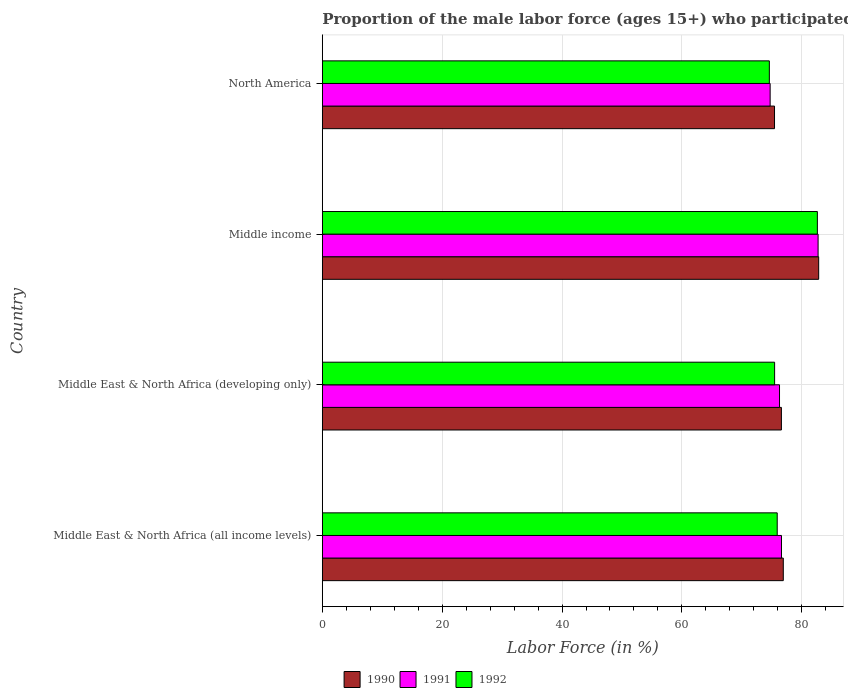How many different coloured bars are there?
Provide a succinct answer. 3. Are the number of bars per tick equal to the number of legend labels?
Offer a very short reply. Yes. Are the number of bars on each tick of the Y-axis equal?
Your answer should be compact. Yes. How many bars are there on the 2nd tick from the top?
Give a very brief answer. 3. What is the label of the 4th group of bars from the top?
Your answer should be very brief. Middle East & North Africa (all income levels). What is the proportion of the male labor force who participated in production in 1991 in Middle East & North Africa (developing only)?
Your answer should be compact. 76.29. Across all countries, what is the maximum proportion of the male labor force who participated in production in 1991?
Make the answer very short. 82.73. Across all countries, what is the minimum proportion of the male labor force who participated in production in 1991?
Give a very brief answer. 74.73. In which country was the proportion of the male labor force who participated in production in 1991 maximum?
Ensure brevity in your answer.  Middle income. What is the total proportion of the male labor force who participated in production in 1990 in the graph?
Keep it short and to the point. 311.83. What is the difference between the proportion of the male labor force who participated in production in 1991 in Middle East & North Africa (all income levels) and that in Middle income?
Ensure brevity in your answer.  -6.11. What is the difference between the proportion of the male labor force who participated in production in 1991 in Middle income and the proportion of the male labor force who participated in production in 1992 in Middle East & North Africa (all income levels)?
Give a very brief answer. 6.82. What is the average proportion of the male labor force who participated in production in 1991 per country?
Offer a terse response. 77.6. What is the difference between the proportion of the male labor force who participated in production in 1990 and proportion of the male labor force who participated in production in 1992 in Middle East & North Africa (developing only)?
Your answer should be compact. 1.13. What is the ratio of the proportion of the male labor force who participated in production in 1991 in Middle East & North Africa (all income levels) to that in Middle income?
Offer a very short reply. 0.93. Is the difference between the proportion of the male labor force who participated in production in 1990 in Middle East & North Africa (all income levels) and North America greater than the difference between the proportion of the male labor force who participated in production in 1992 in Middle East & North Africa (all income levels) and North America?
Give a very brief answer. Yes. What is the difference between the highest and the second highest proportion of the male labor force who participated in production in 1992?
Your answer should be very brief. 6.7. What is the difference between the highest and the lowest proportion of the male labor force who participated in production in 1992?
Your answer should be very brief. 8.02. In how many countries, is the proportion of the male labor force who participated in production in 1992 greater than the average proportion of the male labor force who participated in production in 1992 taken over all countries?
Provide a succinct answer. 1. Is the sum of the proportion of the male labor force who participated in production in 1992 in Middle East & North Africa (all income levels) and North America greater than the maximum proportion of the male labor force who participated in production in 1991 across all countries?
Offer a terse response. Yes. What does the 1st bar from the top in Middle East & North Africa (all income levels) represents?
Your response must be concise. 1992. Is it the case that in every country, the sum of the proportion of the male labor force who participated in production in 1992 and proportion of the male labor force who participated in production in 1991 is greater than the proportion of the male labor force who participated in production in 1990?
Provide a short and direct response. Yes. How many countries are there in the graph?
Provide a succinct answer. 4. Are the values on the major ticks of X-axis written in scientific E-notation?
Give a very brief answer. No. Does the graph contain any zero values?
Your answer should be compact. No. What is the title of the graph?
Your answer should be very brief. Proportion of the male labor force (ages 15+) who participated in production. Does "1995" appear as one of the legend labels in the graph?
Provide a short and direct response. No. What is the label or title of the X-axis?
Provide a succinct answer. Labor Force (in %). What is the Labor Force (in %) of 1990 in Middle East & North Africa (all income levels)?
Offer a terse response. 76.93. What is the Labor Force (in %) of 1991 in Middle East & North Africa (all income levels)?
Ensure brevity in your answer.  76.62. What is the Labor Force (in %) of 1992 in Middle East & North Africa (all income levels)?
Your answer should be very brief. 75.91. What is the Labor Force (in %) of 1990 in Middle East & North Africa (developing only)?
Your response must be concise. 76.61. What is the Labor Force (in %) in 1991 in Middle East & North Africa (developing only)?
Give a very brief answer. 76.29. What is the Labor Force (in %) of 1992 in Middle East & North Africa (developing only)?
Provide a succinct answer. 75.48. What is the Labor Force (in %) of 1990 in Middle income?
Your answer should be very brief. 82.83. What is the Labor Force (in %) of 1991 in Middle income?
Provide a short and direct response. 82.73. What is the Labor Force (in %) of 1992 in Middle income?
Provide a short and direct response. 82.61. What is the Labor Force (in %) of 1990 in North America?
Keep it short and to the point. 75.46. What is the Labor Force (in %) of 1991 in North America?
Your answer should be compact. 74.73. What is the Labor Force (in %) of 1992 in North America?
Offer a terse response. 74.6. Across all countries, what is the maximum Labor Force (in %) in 1990?
Your answer should be very brief. 82.83. Across all countries, what is the maximum Labor Force (in %) in 1991?
Your answer should be compact. 82.73. Across all countries, what is the maximum Labor Force (in %) in 1992?
Ensure brevity in your answer.  82.61. Across all countries, what is the minimum Labor Force (in %) in 1990?
Your answer should be compact. 75.46. Across all countries, what is the minimum Labor Force (in %) in 1991?
Your answer should be compact. 74.73. Across all countries, what is the minimum Labor Force (in %) of 1992?
Your answer should be compact. 74.6. What is the total Labor Force (in %) of 1990 in the graph?
Your answer should be very brief. 311.83. What is the total Labor Force (in %) of 1991 in the graph?
Your answer should be very brief. 310.38. What is the total Labor Force (in %) of 1992 in the graph?
Your answer should be very brief. 308.6. What is the difference between the Labor Force (in %) in 1990 in Middle East & North Africa (all income levels) and that in Middle East & North Africa (developing only)?
Your answer should be compact. 0.32. What is the difference between the Labor Force (in %) of 1991 in Middle East & North Africa (all income levels) and that in Middle East & North Africa (developing only)?
Offer a terse response. 0.33. What is the difference between the Labor Force (in %) in 1992 in Middle East & North Africa (all income levels) and that in Middle East & North Africa (developing only)?
Keep it short and to the point. 0.44. What is the difference between the Labor Force (in %) of 1990 in Middle East & North Africa (all income levels) and that in Middle income?
Your answer should be compact. -5.9. What is the difference between the Labor Force (in %) in 1991 in Middle East & North Africa (all income levels) and that in Middle income?
Offer a very short reply. -6.11. What is the difference between the Labor Force (in %) of 1992 in Middle East & North Africa (all income levels) and that in Middle income?
Offer a terse response. -6.7. What is the difference between the Labor Force (in %) of 1990 in Middle East & North Africa (all income levels) and that in North America?
Provide a short and direct response. 1.46. What is the difference between the Labor Force (in %) in 1991 in Middle East & North Africa (all income levels) and that in North America?
Offer a very short reply. 1.89. What is the difference between the Labor Force (in %) in 1992 in Middle East & North Africa (all income levels) and that in North America?
Offer a very short reply. 1.31. What is the difference between the Labor Force (in %) in 1990 in Middle East & North Africa (developing only) and that in Middle income?
Give a very brief answer. -6.22. What is the difference between the Labor Force (in %) of 1991 in Middle East & North Africa (developing only) and that in Middle income?
Provide a short and direct response. -6.44. What is the difference between the Labor Force (in %) of 1992 in Middle East & North Africa (developing only) and that in Middle income?
Give a very brief answer. -7.14. What is the difference between the Labor Force (in %) in 1990 in Middle East & North Africa (developing only) and that in North America?
Keep it short and to the point. 1.15. What is the difference between the Labor Force (in %) of 1991 in Middle East & North Africa (developing only) and that in North America?
Ensure brevity in your answer.  1.56. What is the difference between the Labor Force (in %) in 1992 in Middle East & North Africa (developing only) and that in North America?
Offer a very short reply. 0.88. What is the difference between the Labor Force (in %) in 1990 in Middle income and that in North America?
Your answer should be compact. 7.37. What is the difference between the Labor Force (in %) in 1991 in Middle income and that in North America?
Offer a terse response. 8. What is the difference between the Labor Force (in %) of 1992 in Middle income and that in North America?
Your response must be concise. 8.02. What is the difference between the Labor Force (in %) of 1990 in Middle East & North Africa (all income levels) and the Labor Force (in %) of 1991 in Middle East & North Africa (developing only)?
Your response must be concise. 0.63. What is the difference between the Labor Force (in %) of 1990 in Middle East & North Africa (all income levels) and the Labor Force (in %) of 1992 in Middle East & North Africa (developing only)?
Give a very brief answer. 1.45. What is the difference between the Labor Force (in %) in 1991 in Middle East & North Africa (all income levels) and the Labor Force (in %) in 1992 in Middle East & North Africa (developing only)?
Your answer should be very brief. 1.15. What is the difference between the Labor Force (in %) in 1990 in Middle East & North Africa (all income levels) and the Labor Force (in %) in 1991 in Middle income?
Ensure brevity in your answer.  -5.81. What is the difference between the Labor Force (in %) of 1990 in Middle East & North Africa (all income levels) and the Labor Force (in %) of 1992 in Middle income?
Give a very brief answer. -5.69. What is the difference between the Labor Force (in %) in 1991 in Middle East & North Africa (all income levels) and the Labor Force (in %) in 1992 in Middle income?
Give a very brief answer. -5.99. What is the difference between the Labor Force (in %) in 1990 in Middle East & North Africa (all income levels) and the Labor Force (in %) in 1991 in North America?
Your response must be concise. 2.2. What is the difference between the Labor Force (in %) in 1990 in Middle East & North Africa (all income levels) and the Labor Force (in %) in 1992 in North America?
Keep it short and to the point. 2.33. What is the difference between the Labor Force (in %) in 1991 in Middle East & North Africa (all income levels) and the Labor Force (in %) in 1992 in North America?
Provide a succinct answer. 2.03. What is the difference between the Labor Force (in %) of 1990 in Middle East & North Africa (developing only) and the Labor Force (in %) of 1991 in Middle income?
Your answer should be compact. -6.12. What is the difference between the Labor Force (in %) in 1990 in Middle East & North Africa (developing only) and the Labor Force (in %) in 1992 in Middle income?
Provide a short and direct response. -6. What is the difference between the Labor Force (in %) in 1991 in Middle East & North Africa (developing only) and the Labor Force (in %) in 1992 in Middle income?
Your answer should be compact. -6.32. What is the difference between the Labor Force (in %) of 1990 in Middle East & North Africa (developing only) and the Labor Force (in %) of 1991 in North America?
Your answer should be compact. 1.88. What is the difference between the Labor Force (in %) in 1990 in Middle East & North Africa (developing only) and the Labor Force (in %) in 1992 in North America?
Ensure brevity in your answer.  2.01. What is the difference between the Labor Force (in %) in 1991 in Middle East & North Africa (developing only) and the Labor Force (in %) in 1992 in North America?
Your answer should be compact. 1.7. What is the difference between the Labor Force (in %) of 1990 in Middle income and the Labor Force (in %) of 1991 in North America?
Your answer should be compact. 8.1. What is the difference between the Labor Force (in %) in 1990 in Middle income and the Labor Force (in %) in 1992 in North America?
Give a very brief answer. 8.23. What is the difference between the Labor Force (in %) of 1991 in Middle income and the Labor Force (in %) of 1992 in North America?
Your answer should be very brief. 8.14. What is the average Labor Force (in %) of 1990 per country?
Give a very brief answer. 77.96. What is the average Labor Force (in %) in 1991 per country?
Give a very brief answer. 77.6. What is the average Labor Force (in %) in 1992 per country?
Your answer should be very brief. 77.15. What is the difference between the Labor Force (in %) of 1990 and Labor Force (in %) of 1991 in Middle East & North Africa (all income levels)?
Your answer should be very brief. 0.3. What is the difference between the Labor Force (in %) in 1990 and Labor Force (in %) in 1992 in Middle East & North Africa (all income levels)?
Keep it short and to the point. 1.01. What is the difference between the Labor Force (in %) of 1991 and Labor Force (in %) of 1992 in Middle East & North Africa (all income levels)?
Keep it short and to the point. 0.71. What is the difference between the Labor Force (in %) in 1990 and Labor Force (in %) in 1991 in Middle East & North Africa (developing only)?
Provide a succinct answer. 0.31. What is the difference between the Labor Force (in %) in 1990 and Labor Force (in %) in 1992 in Middle East & North Africa (developing only)?
Your answer should be compact. 1.13. What is the difference between the Labor Force (in %) of 1991 and Labor Force (in %) of 1992 in Middle East & North Africa (developing only)?
Give a very brief answer. 0.82. What is the difference between the Labor Force (in %) of 1990 and Labor Force (in %) of 1991 in Middle income?
Keep it short and to the point. 0.1. What is the difference between the Labor Force (in %) in 1990 and Labor Force (in %) in 1992 in Middle income?
Make the answer very short. 0.22. What is the difference between the Labor Force (in %) of 1991 and Labor Force (in %) of 1992 in Middle income?
Provide a succinct answer. 0.12. What is the difference between the Labor Force (in %) in 1990 and Labor Force (in %) in 1991 in North America?
Keep it short and to the point. 0.73. What is the difference between the Labor Force (in %) in 1990 and Labor Force (in %) in 1992 in North America?
Offer a very short reply. 0.86. What is the difference between the Labor Force (in %) of 1991 and Labor Force (in %) of 1992 in North America?
Your answer should be very brief. 0.13. What is the ratio of the Labor Force (in %) of 1990 in Middle East & North Africa (all income levels) to that in Middle East & North Africa (developing only)?
Offer a very short reply. 1. What is the ratio of the Labor Force (in %) of 1991 in Middle East & North Africa (all income levels) to that in Middle East & North Africa (developing only)?
Your response must be concise. 1. What is the ratio of the Labor Force (in %) of 1990 in Middle East & North Africa (all income levels) to that in Middle income?
Give a very brief answer. 0.93. What is the ratio of the Labor Force (in %) of 1991 in Middle East & North Africa (all income levels) to that in Middle income?
Your response must be concise. 0.93. What is the ratio of the Labor Force (in %) of 1992 in Middle East & North Africa (all income levels) to that in Middle income?
Keep it short and to the point. 0.92. What is the ratio of the Labor Force (in %) of 1990 in Middle East & North Africa (all income levels) to that in North America?
Your response must be concise. 1.02. What is the ratio of the Labor Force (in %) of 1991 in Middle East & North Africa (all income levels) to that in North America?
Provide a succinct answer. 1.03. What is the ratio of the Labor Force (in %) of 1992 in Middle East & North Africa (all income levels) to that in North America?
Give a very brief answer. 1.02. What is the ratio of the Labor Force (in %) of 1990 in Middle East & North Africa (developing only) to that in Middle income?
Keep it short and to the point. 0.92. What is the ratio of the Labor Force (in %) in 1991 in Middle East & North Africa (developing only) to that in Middle income?
Make the answer very short. 0.92. What is the ratio of the Labor Force (in %) in 1992 in Middle East & North Africa (developing only) to that in Middle income?
Your response must be concise. 0.91. What is the ratio of the Labor Force (in %) of 1990 in Middle East & North Africa (developing only) to that in North America?
Give a very brief answer. 1.02. What is the ratio of the Labor Force (in %) of 1991 in Middle East & North Africa (developing only) to that in North America?
Your answer should be very brief. 1.02. What is the ratio of the Labor Force (in %) in 1992 in Middle East & North Africa (developing only) to that in North America?
Offer a very short reply. 1.01. What is the ratio of the Labor Force (in %) in 1990 in Middle income to that in North America?
Make the answer very short. 1.1. What is the ratio of the Labor Force (in %) in 1991 in Middle income to that in North America?
Provide a short and direct response. 1.11. What is the ratio of the Labor Force (in %) of 1992 in Middle income to that in North America?
Ensure brevity in your answer.  1.11. What is the difference between the highest and the second highest Labor Force (in %) in 1990?
Keep it short and to the point. 5.9. What is the difference between the highest and the second highest Labor Force (in %) in 1991?
Ensure brevity in your answer.  6.11. What is the difference between the highest and the second highest Labor Force (in %) of 1992?
Offer a terse response. 6.7. What is the difference between the highest and the lowest Labor Force (in %) of 1990?
Ensure brevity in your answer.  7.37. What is the difference between the highest and the lowest Labor Force (in %) in 1991?
Keep it short and to the point. 8. What is the difference between the highest and the lowest Labor Force (in %) of 1992?
Offer a very short reply. 8.02. 